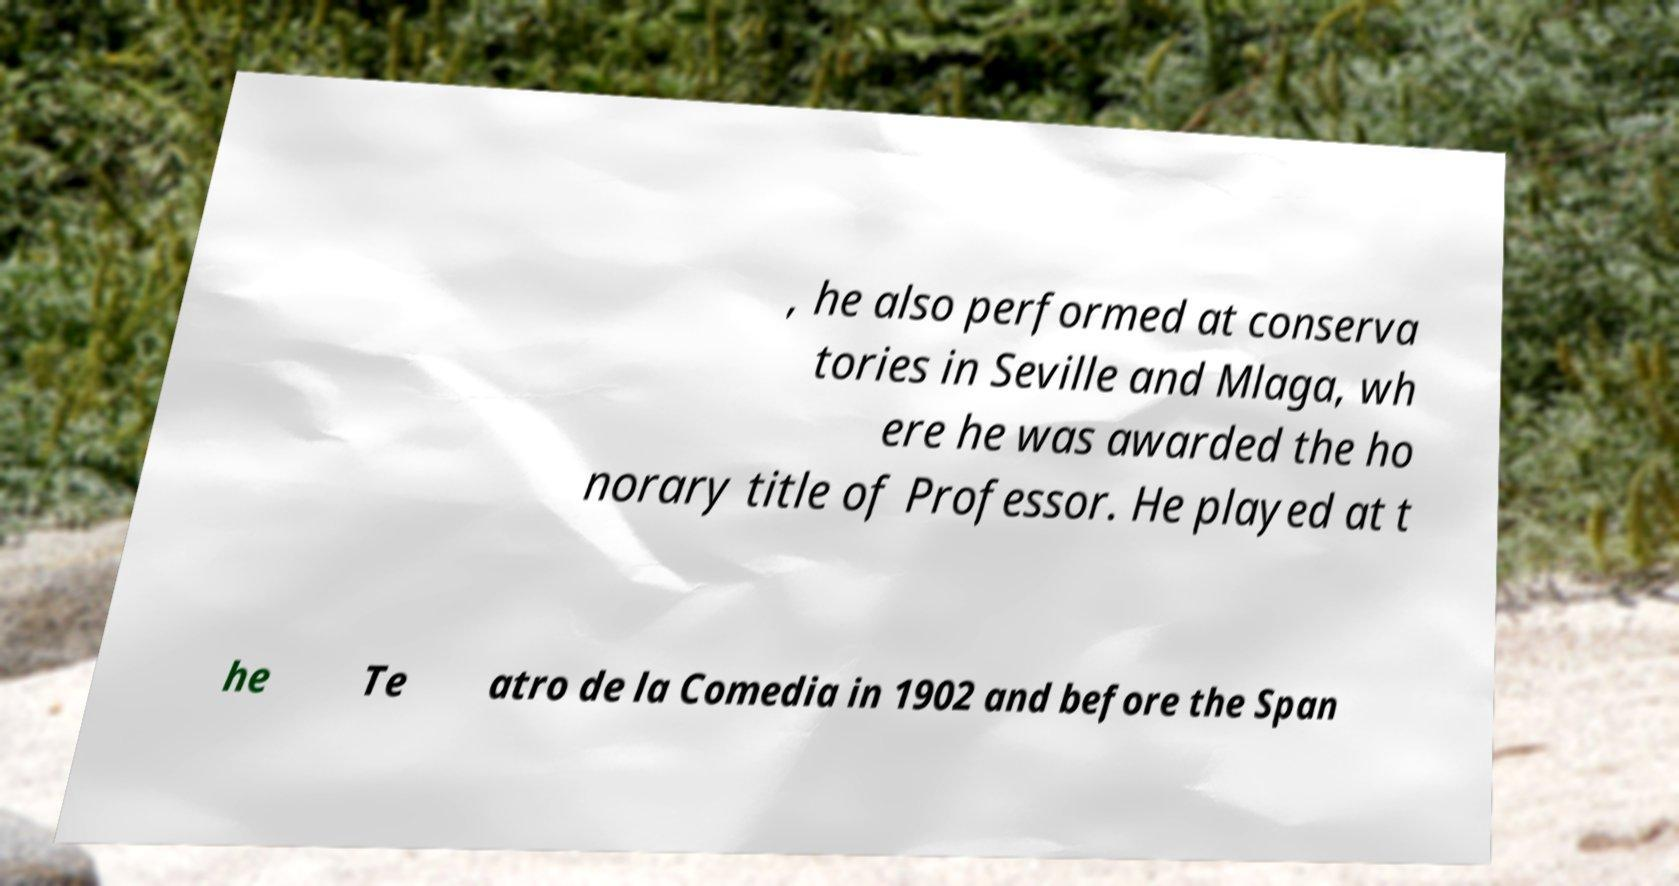Could you assist in decoding the text presented in this image and type it out clearly? , he also performed at conserva tories in Seville and Mlaga, wh ere he was awarded the ho norary title of Professor. He played at t he Te atro de la Comedia in 1902 and before the Span 